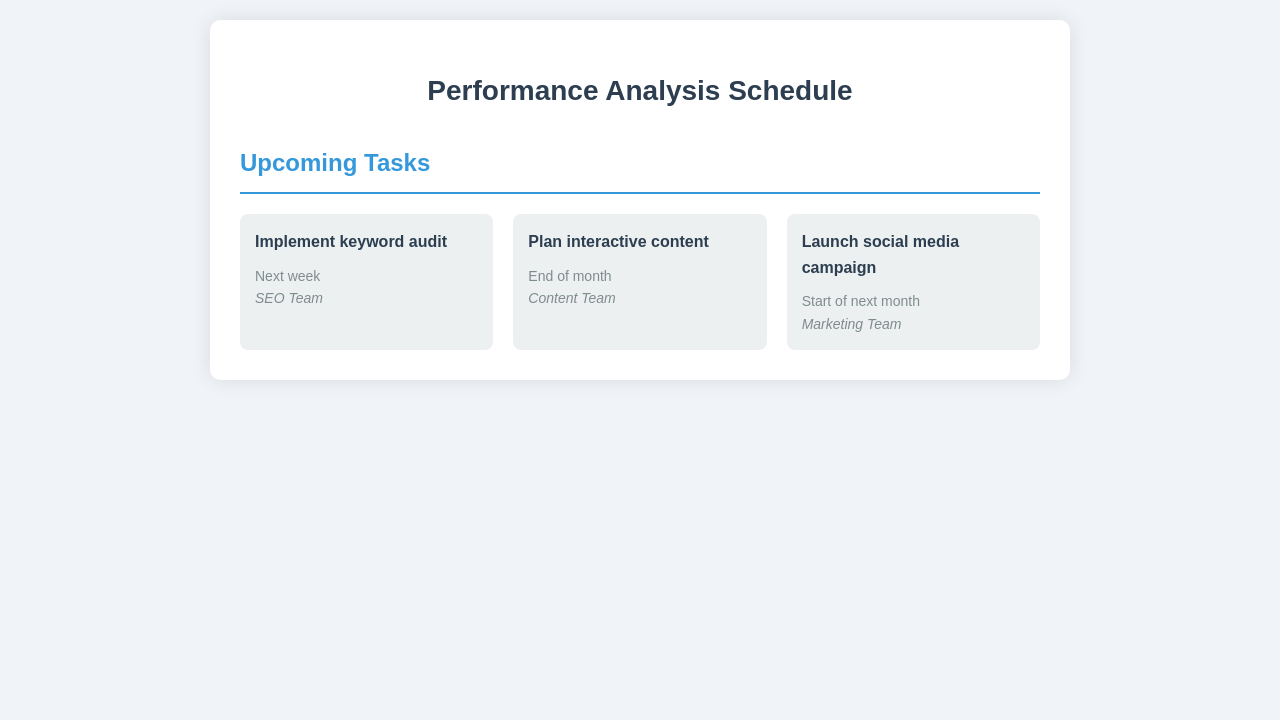What is the first task listed in the schedule? The first task listed in the schedule is the one at the top, which is to implement a keyword audit.
Answer: Implement keyword audit Who is responsible for planning interactive content? The schedule specifies that the Content Team is responsible for this task.
Answer: Content Team When is the social media campaign set to launch? The launch date for the social media campaign is indicated as the start of next month.
Answer: Start of next month What color is used for the task titles in the schedule? The task titles are formatted in bold and are colored #2c3e50.
Answer: #2c3e50 How many tasks are listed in the upcoming tasks section? There are three tasks listed in the upcoming tasks section of the document.
Answer: Three Which team is responsible for the keyword audit? The document states that the SEO Team is responsible for implementing the keyword audit.
Answer: SEO Team What is the date for the implementation of the keyword audit? The schedule indicates this task is set for next week.
Answer: Next week What is the background color of the schedule items? The schedule items have a light grey background color indicated as #ecf0f1.
Answer: #ecf0f1 